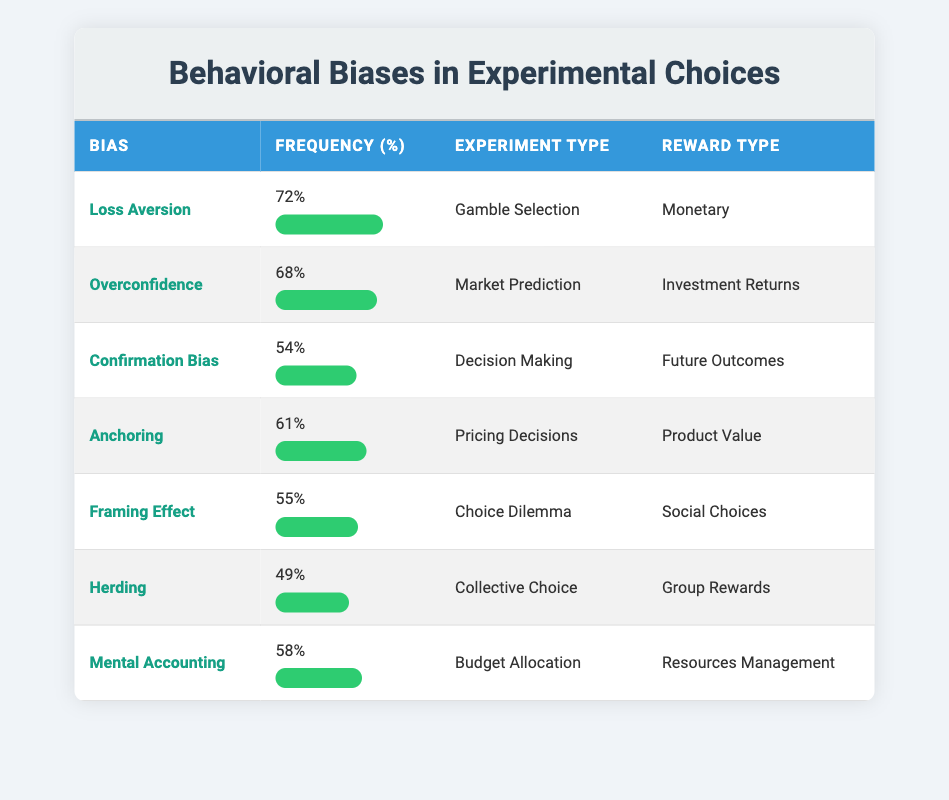What is the frequency percentage of Loss Aversion? The table states that Loss Aversion has a frequency percentage of 72%.
Answer: 72% Which behavioral bias has the lowest frequency percentage? By examining the frequency percentages listed, Herding has the lowest at 49%.
Answer: 49% What is the average frequency percentage of the biases listed in the table? To calculate the average, sum all the frequencies: (72 + 68 + 54 + 61 + 55 + 49 + 58) =  387. There are 7 biases, so the average is 387 / 7 ≈ 55.29.
Answer: Approximately 55.29 Is Overconfidence observed more frequently than Mental Accounting? Overconfidence has a frequency of 68%, while Mental Accounting has 58%. Since 68% is greater than 58%, the statement is true.
Answer: Yes Which experiment type is associated with the Framing Effect? The table shows that the Framing Effect is linked to the experiment type "Choice Dilemma".
Answer: Choice Dilemma What is the total frequency percentage of biases related to monetary rewards? The biases linked to monetary rewards are Loss Aversion (72%) and Mental Accounting (58%). Their total percentage is 72 + 58 = 130.
Answer: 130 What is the frequency percentage difference between Anchoring and Confirmation Bias? Anchoring has a frequency of 61%, while Confirmation Bias has 54%. The difference is calculated as 61 - 54 = 7.
Answer: 7 Are there more biases related to Monetary rewards than to Social Choices? The table indicates that only Loss Aversion is a monetary reward, while Framing Effect is related to Social Choices. Therefore, there is 1 bias for Monetary and 1 for Social, making the answer false.
Answer: No Which two biases have similar frequency percentages, and what are they? Framing Effect at 55% and Mental Accounting at 58% are close. When considering the variations, these two are the closest in values.
Answer: Framing Effect and Mental Accounting 